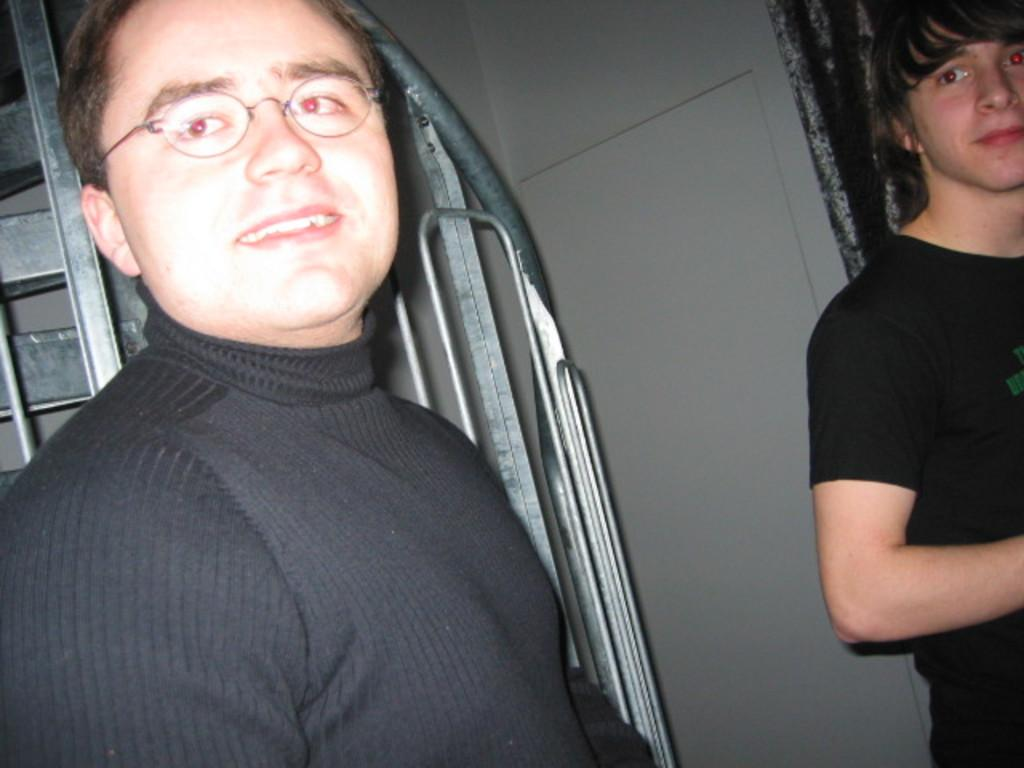How many people are present in the image? There are two people in the image. What can be seen in the background of the image? There is a wall, a curtain, and metal objects in the background of the image. What type of jeans are the people wearing in the image? There is no information about the type of jeans the people are wearing in the image. 